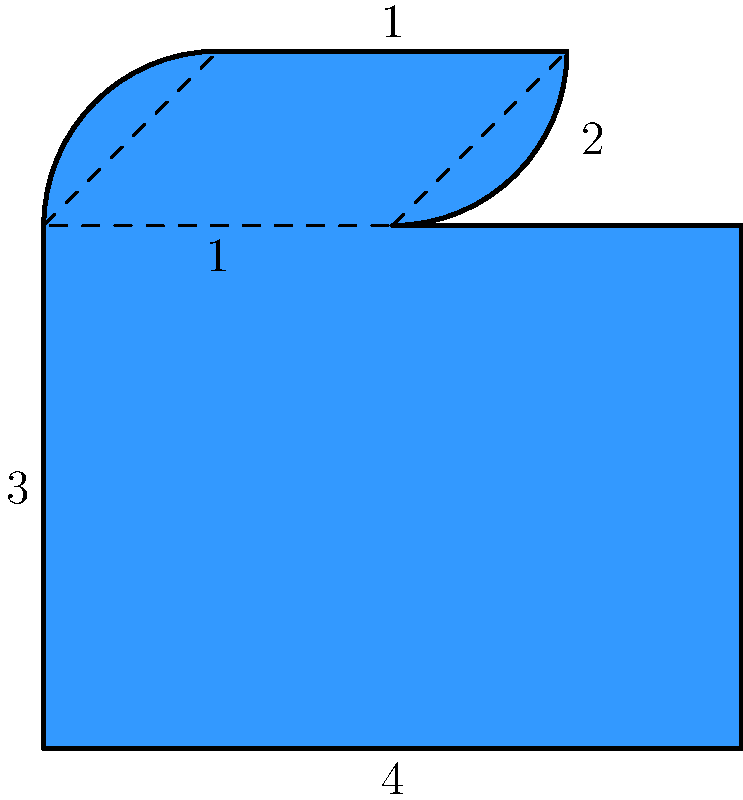As a social media influencer, you're designing a custom "like" button for your brand. The button is shaped like an asymmetrical heart, as shown in the diagram. The base is a 4x3 rectangle, with a curved top portion. If each unit in the diagram represents 10 pixels, what is the total area of the "like" button in square pixels? Let's break this down step-by-step:

1) First, we need to calculate the area of the base rectangle:
   Area of rectangle = length × width
   $A_r = 4 \times 3 = 12$ square units

2) Now, we need to calculate the area of the top curved portion. We can approximate this by dividing it into two parts:
   a) A rectangle: 2 × 1 = 2 square units
   b) Two triangles: $2 \times (\frac{1 \times 1}{2}) = 1$ square unit

3) The total area of the curved top portion is:
   $A_t = 2 + 1 = 3$ square units

4) The total area of the "like" button is the sum of these areas:
   $A_{total} = A_r + A_t = 12 + 3 = 15$ square units

5) Since each unit represents 10 pixels, we need to multiply our result by 100:
   $A_{pixels} = 15 \times 100 = 1500$ square pixels

Therefore, the total area of the "like" button is 1500 square pixels.
Answer: 1500 square pixels 